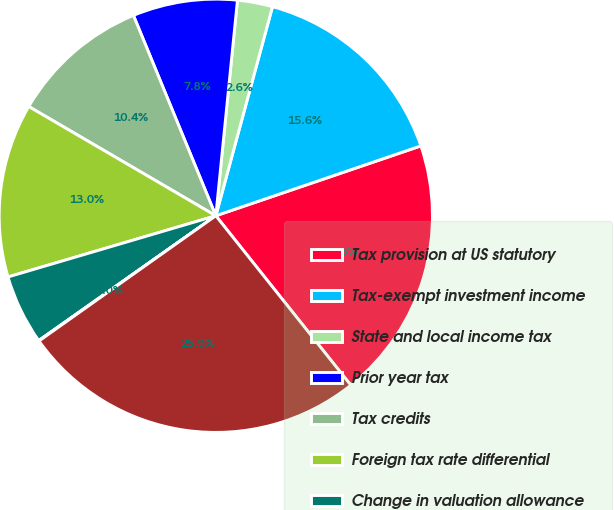Convert chart. <chart><loc_0><loc_0><loc_500><loc_500><pie_chart><fcel>Tax provision at US statutory<fcel>Tax-exempt investment income<fcel>State and local income tax<fcel>Prior year tax<fcel>Tax credits<fcel>Foreign tax rate differential<fcel>Change in valuation allowance<fcel>Other net<fcel>Provision for income tax<nl><fcel>19.52%<fcel>15.56%<fcel>2.62%<fcel>7.8%<fcel>10.38%<fcel>12.97%<fcel>5.21%<fcel>0.04%<fcel>25.9%<nl></chart> 